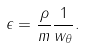Convert formula to latex. <formula><loc_0><loc_0><loc_500><loc_500>\epsilon = \frac { \rho } { m } \frac { 1 } { w _ { \theta } } .</formula> 